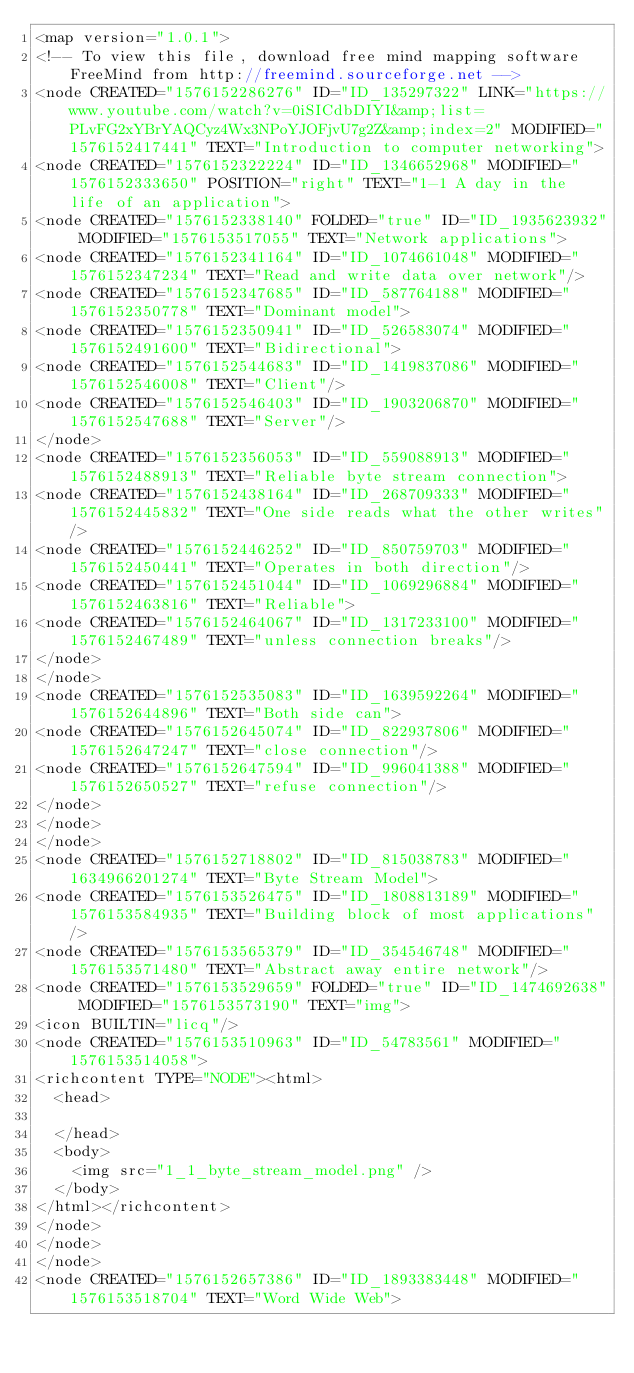<code> <loc_0><loc_0><loc_500><loc_500><_ObjectiveC_><map version="1.0.1">
<!-- To view this file, download free mind mapping software FreeMind from http://freemind.sourceforge.net -->
<node CREATED="1576152286276" ID="ID_135297322" LINK="https://www.youtube.com/watch?v=0iSICdbDIYI&amp;list=PLvFG2xYBrYAQCyz4Wx3NPoYJOFjvU7g2Z&amp;index=2" MODIFIED="1576152417441" TEXT="Introduction to computer networking">
<node CREATED="1576152322224" ID="ID_1346652968" MODIFIED="1576152333650" POSITION="right" TEXT="1-1 A day in the life of an application">
<node CREATED="1576152338140" FOLDED="true" ID="ID_1935623932" MODIFIED="1576153517055" TEXT="Network applications">
<node CREATED="1576152341164" ID="ID_1074661048" MODIFIED="1576152347234" TEXT="Read and write data over network"/>
<node CREATED="1576152347685" ID="ID_587764188" MODIFIED="1576152350778" TEXT="Dominant model">
<node CREATED="1576152350941" ID="ID_526583074" MODIFIED="1576152491600" TEXT="Bidirectional">
<node CREATED="1576152544683" ID="ID_1419837086" MODIFIED="1576152546008" TEXT="Client"/>
<node CREATED="1576152546403" ID="ID_1903206870" MODIFIED="1576152547688" TEXT="Server"/>
</node>
<node CREATED="1576152356053" ID="ID_559088913" MODIFIED="1576152488913" TEXT="Reliable byte stream connection">
<node CREATED="1576152438164" ID="ID_268709333" MODIFIED="1576152445832" TEXT="One side reads what the other writes"/>
<node CREATED="1576152446252" ID="ID_850759703" MODIFIED="1576152450441" TEXT="Operates in both direction"/>
<node CREATED="1576152451044" ID="ID_1069296884" MODIFIED="1576152463816" TEXT="Reliable">
<node CREATED="1576152464067" ID="ID_1317233100" MODIFIED="1576152467489" TEXT="unless connection breaks"/>
</node>
</node>
<node CREATED="1576152535083" ID="ID_1639592264" MODIFIED="1576152644896" TEXT="Both side can">
<node CREATED="1576152645074" ID="ID_822937806" MODIFIED="1576152647247" TEXT="close connection"/>
<node CREATED="1576152647594" ID="ID_996041388" MODIFIED="1576152650527" TEXT="refuse connection"/>
</node>
</node>
</node>
<node CREATED="1576152718802" ID="ID_815038783" MODIFIED="1634966201274" TEXT="Byte Stream Model">
<node CREATED="1576153526475" ID="ID_1808813189" MODIFIED="1576153584935" TEXT="Building block of most applications"/>
<node CREATED="1576153565379" ID="ID_354546748" MODIFIED="1576153571480" TEXT="Abstract away entire network"/>
<node CREATED="1576153529659" FOLDED="true" ID="ID_1474692638" MODIFIED="1576153573190" TEXT="img">
<icon BUILTIN="licq"/>
<node CREATED="1576153510963" ID="ID_54783561" MODIFIED="1576153514058">
<richcontent TYPE="NODE"><html>
  <head>
    
  </head>
  <body>
    <img src="1_1_byte_stream_model.png" />
  </body>
</html></richcontent>
</node>
</node>
</node>
<node CREATED="1576152657386" ID="ID_1893383448" MODIFIED="1576153518704" TEXT="Word Wide Web"></code> 